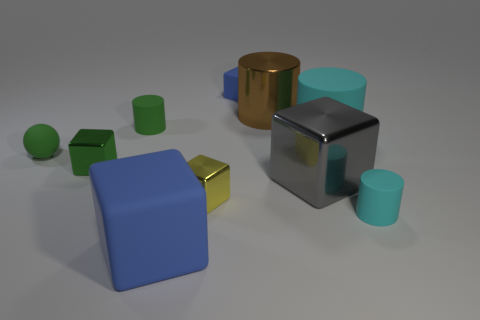There is another cube that is the same color as the small matte cube; what is it made of?
Your answer should be very brief. Rubber. There is a cyan matte thing that is the same size as the green block; what shape is it?
Your answer should be very brief. Cylinder. What shape is the small green rubber object that is on the left side of the cylinder that is on the left side of the brown thing?
Provide a succinct answer. Sphere. Does the green metal cube have the same size as the blue rubber block that is in front of the small blue matte object?
Keep it short and to the point. No. What is the brown cylinder behind the tiny matte sphere made of?
Ensure brevity in your answer.  Metal. What number of big blocks are both right of the large brown metallic object and on the left side of the gray shiny block?
Ensure brevity in your answer.  0. There is a gray thing that is the same size as the brown cylinder; what is its material?
Provide a succinct answer. Metal. Does the blue thing that is behind the big blue rubber thing have the same size as the blue rubber thing that is in front of the brown thing?
Make the answer very short. No. There is a small green matte cylinder; are there any big blue matte things behind it?
Ensure brevity in your answer.  No. What is the color of the big metal block that is left of the cyan cylinder that is in front of the green sphere?
Ensure brevity in your answer.  Gray. 